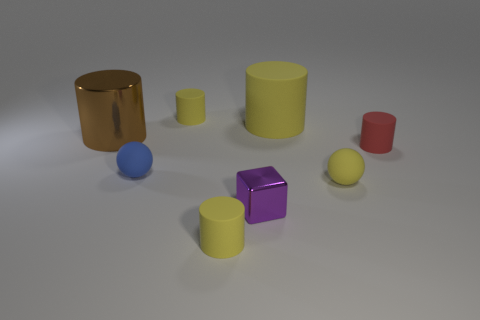Subtract all yellow spheres. How many yellow cylinders are left? 3 Subtract all red cylinders. How many cylinders are left? 4 Subtract all big shiny cylinders. How many cylinders are left? 4 Add 1 big purple spheres. How many objects exist? 9 Subtract all brown cylinders. Subtract all cyan spheres. How many cylinders are left? 4 Subtract all cylinders. How many objects are left? 3 Subtract all small rubber spheres. Subtract all purple metallic things. How many objects are left? 5 Add 8 big objects. How many big objects are left? 10 Add 3 small objects. How many small objects exist? 9 Subtract 1 red cylinders. How many objects are left? 7 